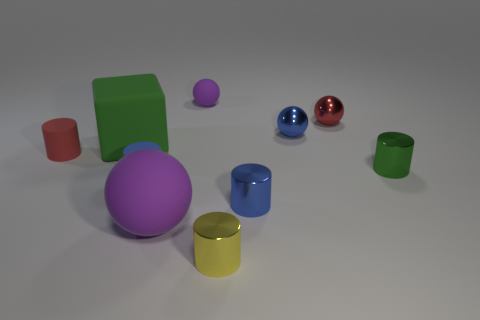Can you tell me which objects are blue and what their shapes are? In the image, there are two blue objects. One is a blue sphere, and the other is a blue cylinder. 